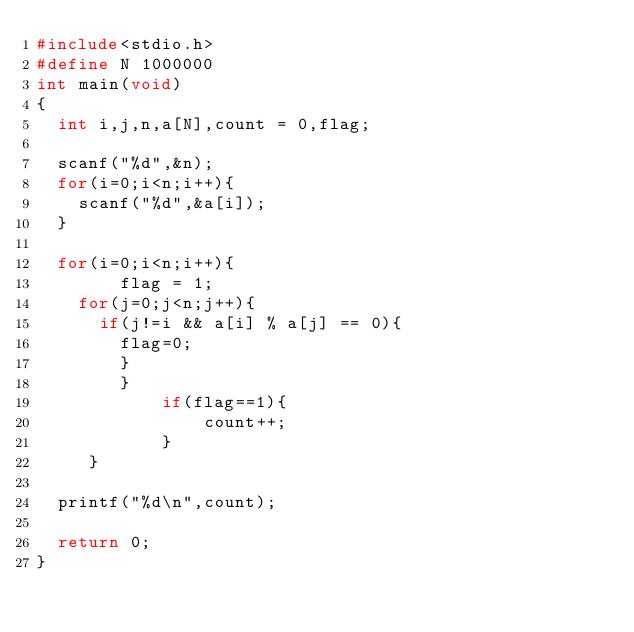<code> <loc_0><loc_0><loc_500><loc_500><_C_>#include<stdio.h>
#define N 1000000
int main(void)
{
  int i,j,n,a[N],count = 0,flag;

  scanf("%d",&n);
  for(i=0;i<n;i++){
    scanf("%d",&a[i]);
  }

  for(i=0;i<n;i++){
		flag = 1;
    for(j=0;j<n;j++){
      if(j!=i && a[i] % a[j] == 0){
        flag=0; 
      	} 
    	}
			if(flag==1){
				count++;
			}
	 }

  printf("%d\n",count);
  
  return 0;
}</code> 